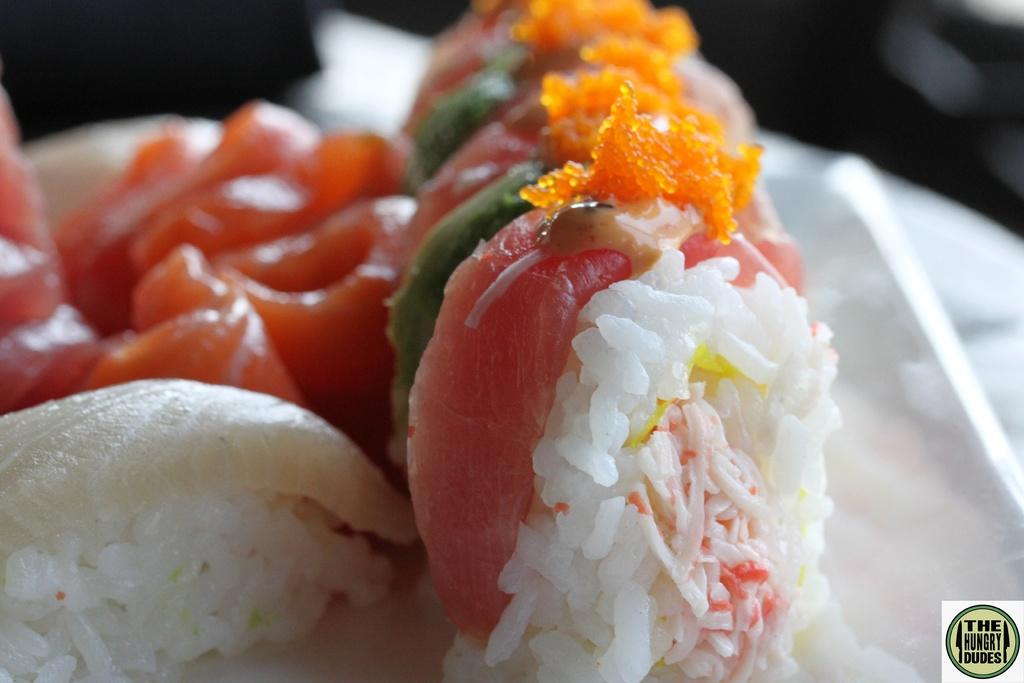What type of food can be seen in the image? There is rice in the image. Are there any other food items visible in the image? Yes, there are food items in the image. Can you describe the background of the image? The background of the image is not clear enough to describe the objects. How many houses can be seen in the image? There are no houses present in the image. What type of fruit is being smashed in the image? There is no fruit being smashed in the image. 